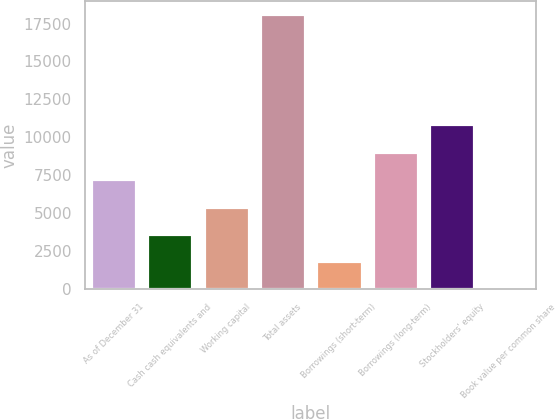<chart> <loc_0><loc_0><loc_500><loc_500><bar_chart><fcel>As of December 31<fcel>Cash cash equivalents and<fcel>Working capital<fcel>Total assets<fcel>Borrowings (short-term)<fcel>Borrowings (long-term)<fcel>Stockholders' equity<fcel>Book value per common share<nl><fcel>7241.38<fcel>3623.16<fcel>5432.27<fcel>18096<fcel>1814.05<fcel>9050.49<fcel>10859.6<fcel>4.94<nl></chart> 